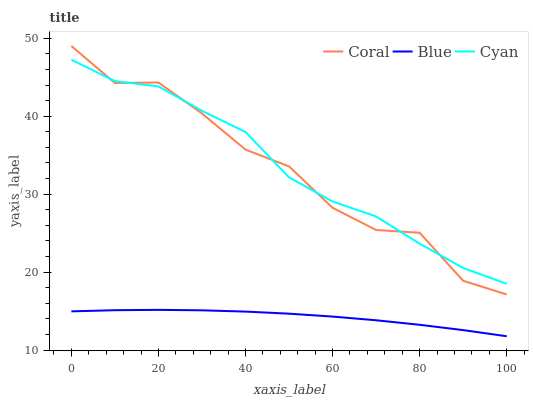Does Blue have the minimum area under the curve?
Answer yes or no. Yes. Does Cyan have the maximum area under the curve?
Answer yes or no. Yes. Does Coral have the minimum area under the curve?
Answer yes or no. No. Does Coral have the maximum area under the curve?
Answer yes or no. No. Is Blue the smoothest?
Answer yes or no. Yes. Is Coral the roughest?
Answer yes or no. Yes. Is Cyan the smoothest?
Answer yes or no. No. Is Cyan the roughest?
Answer yes or no. No. Does Blue have the lowest value?
Answer yes or no. Yes. Does Coral have the lowest value?
Answer yes or no. No. Does Coral have the highest value?
Answer yes or no. Yes. Does Cyan have the highest value?
Answer yes or no. No. Is Blue less than Cyan?
Answer yes or no. Yes. Is Coral greater than Blue?
Answer yes or no. Yes. Does Cyan intersect Coral?
Answer yes or no. Yes. Is Cyan less than Coral?
Answer yes or no. No. Is Cyan greater than Coral?
Answer yes or no. No. Does Blue intersect Cyan?
Answer yes or no. No. 